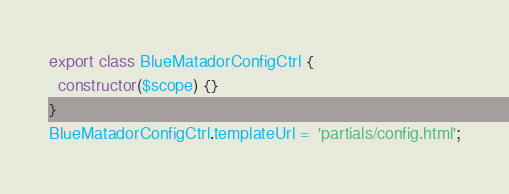Convert code to text. <code><loc_0><loc_0><loc_500><loc_500><_JavaScript_>export class BlueMatadorConfigCtrl {
  constructor($scope) {}
}
BlueMatadorConfigCtrl.templateUrl =  'partials/config.html';
</code> 